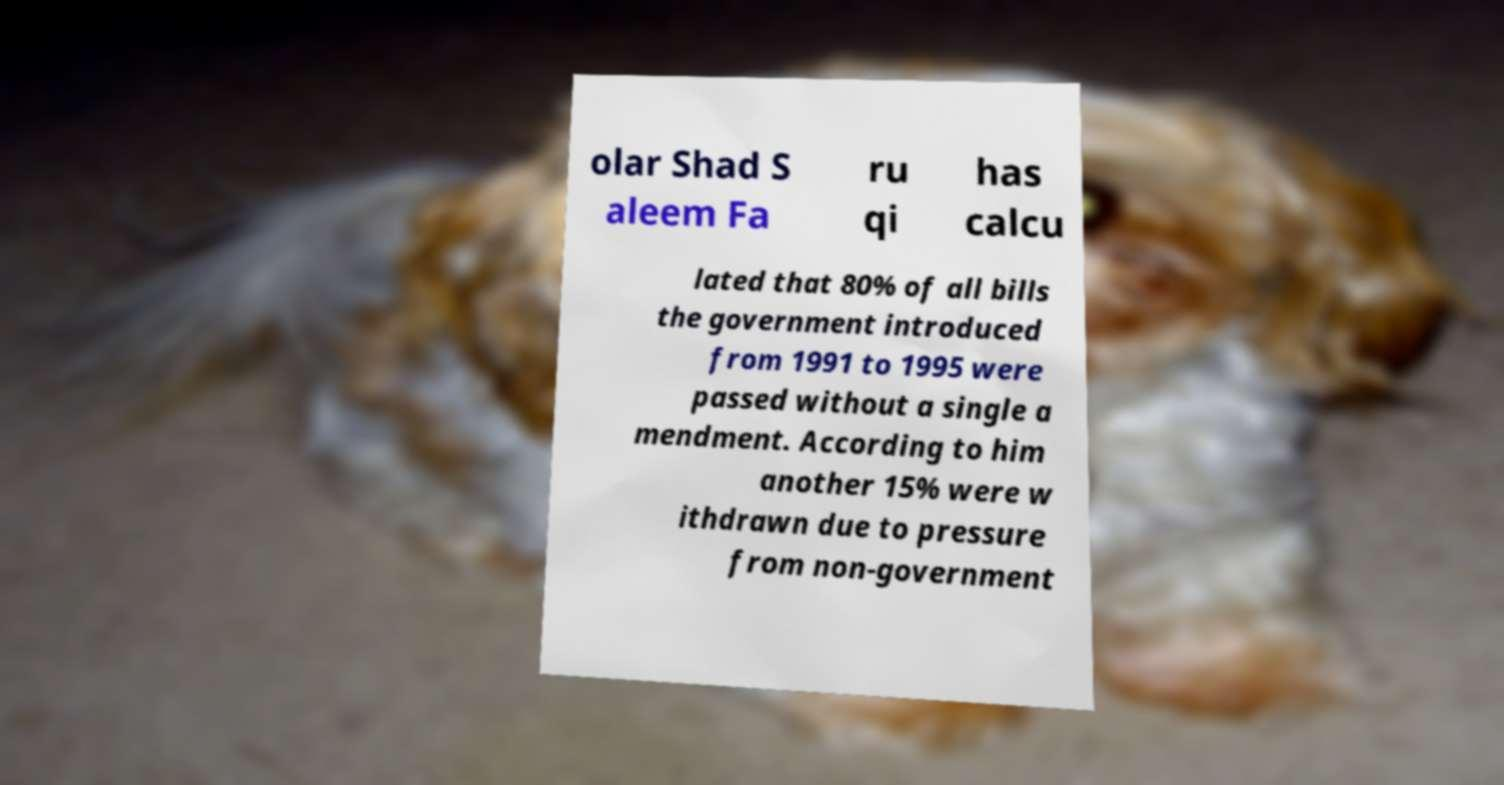What messages or text are displayed in this image? I need them in a readable, typed format. olar Shad S aleem Fa ru qi has calcu lated that 80% of all bills the government introduced from 1991 to 1995 were passed without a single a mendment. According to him another 15% were w ithdrawn due to pressure from non-government 